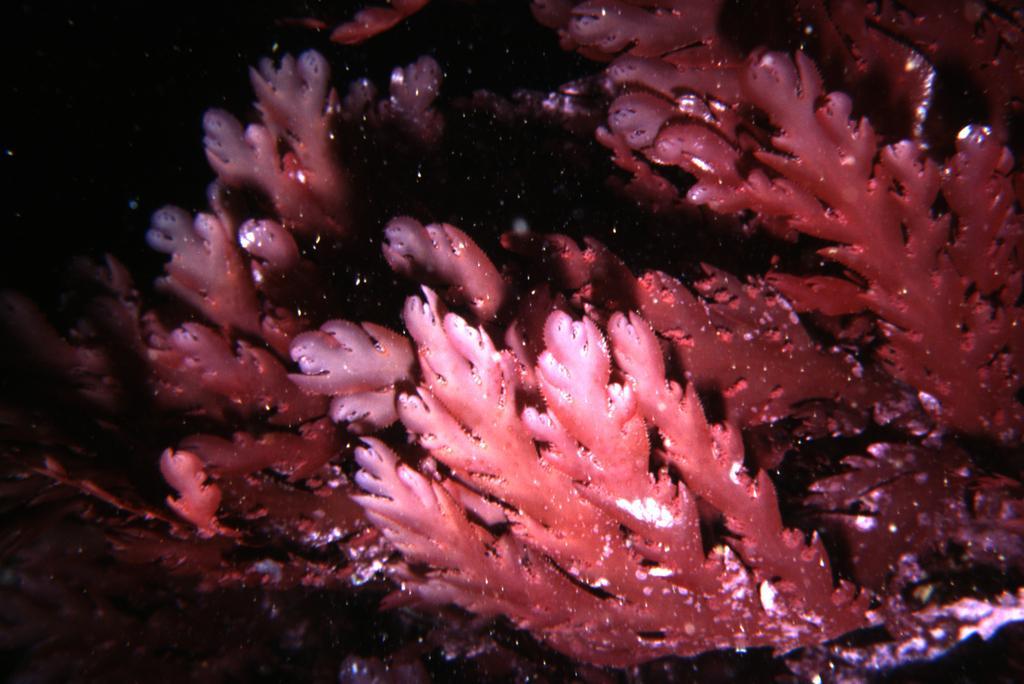Can you describe this image briefly? The picture is taken under water, in the picture there are water plants. On the left it is dark. 